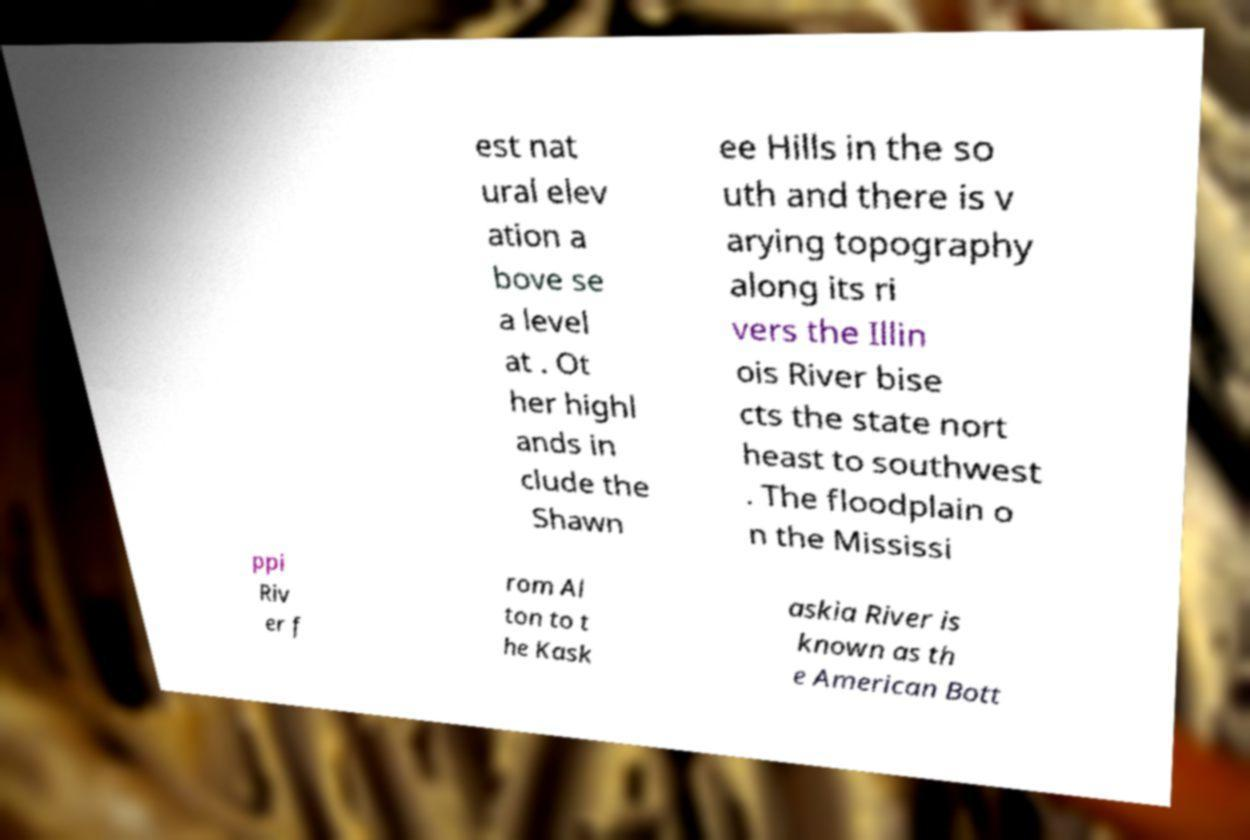For documentation purposes, I need the text within this image transcribed. Could you provide that? est nat ural elev ation a bove se a level at . Ot her highl ands in clude the Shawn ee Hills in the so uth and there is v arying topography along its ri vers the Illin ois River bise cts the state nort heast to southwest . The floodplain o n the Mississi ppi Riv er f rom Al ton to t he Kask askia River is known as th e American Bott 